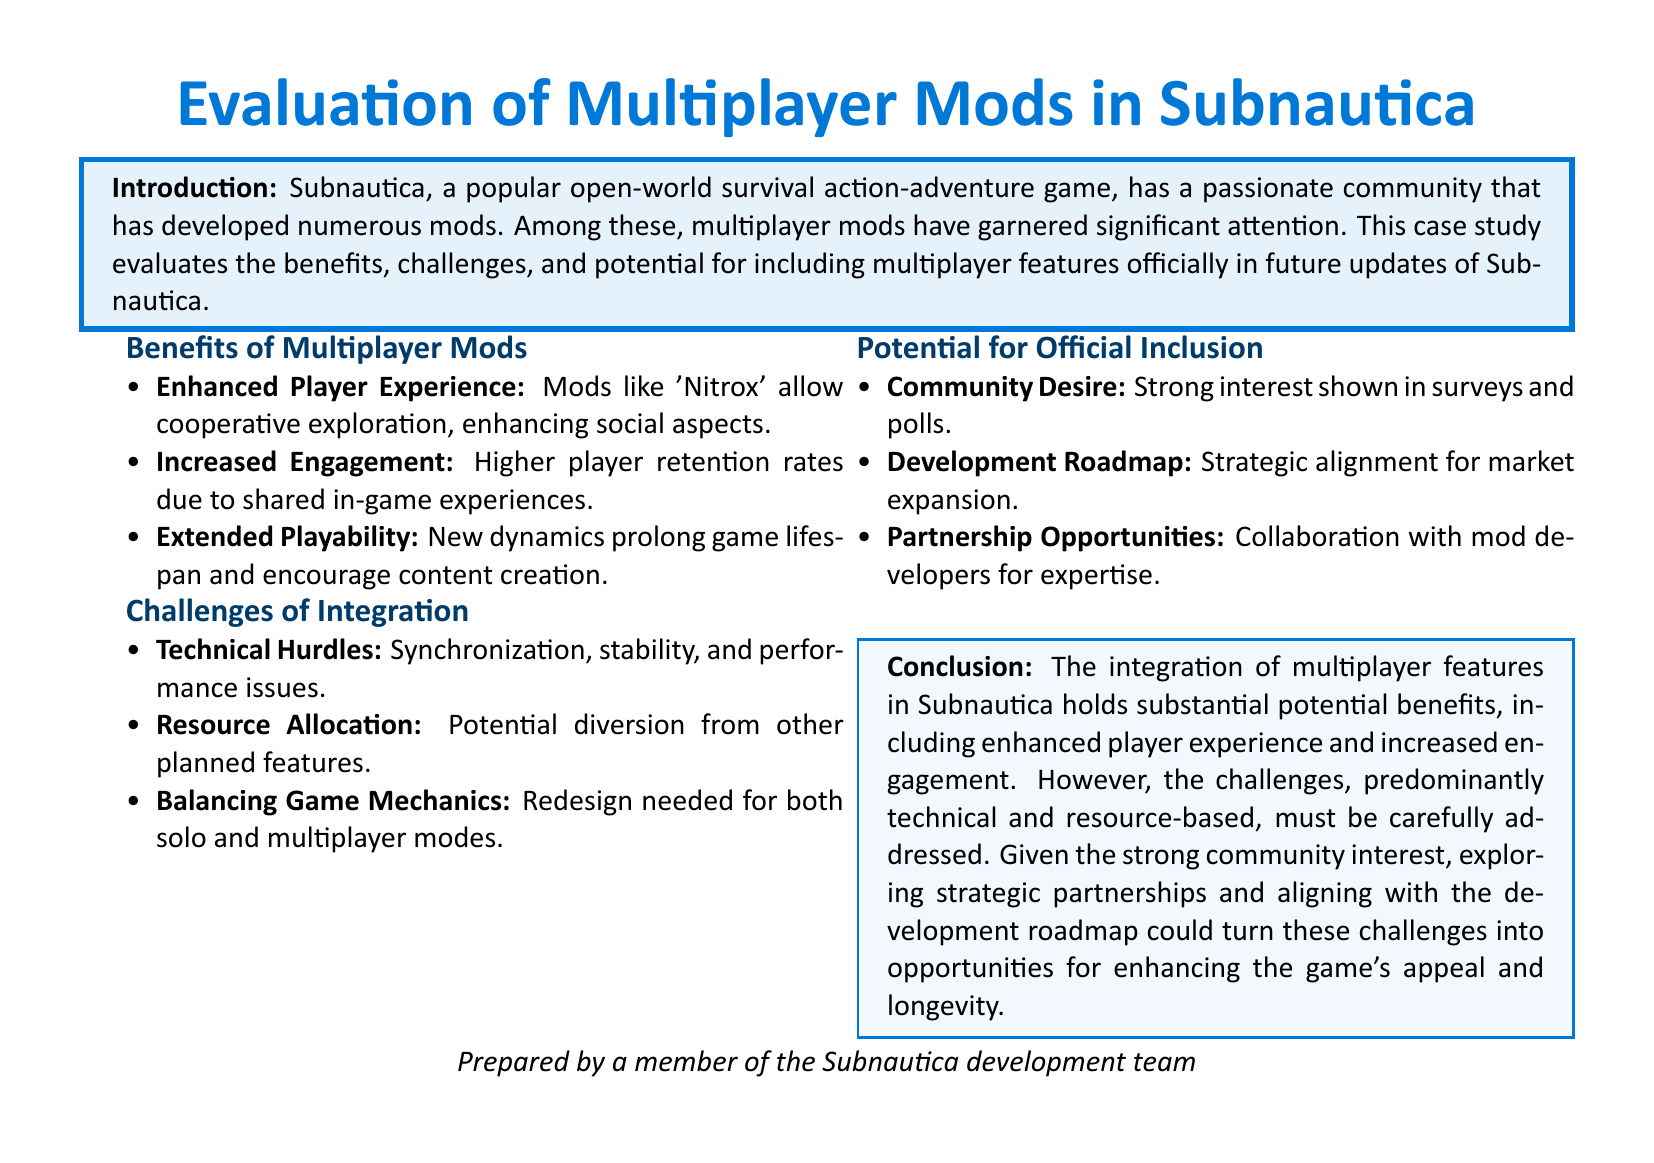What is the title of the case study? The title of the case study is provided at the beginning of the document.
Answer: Evaluation of Multiplayer Mods in Subnautica What mod is mentioned as allowing cooperative exploration? The mod referred to for cooperative exploration is named explicitly in the benefits section.
Answer: Nitrox What color is used for the header background? The color defined for the header background is specified in the document.
Answer: subnauticablue What is one benefit of multiplayer mods mentioned? Benefits listed in the document include enhancements to gameplay, which can be referenced from the benefits section.
Answer: Enhanced Player Experience What is one challenge of integration identified? The document clearly outlines the challenges in the integration section, where one challenge is explicitly stated.
Answer: Technical Hurdles According to the conclusion, what is the conclusion about community interest? Insights about community interest are provided in the conclusion, highlighting its significance.
Answer: Strong community interest What does the document suggest for strategic partnerships? The potential for collaboration with mod developers is outlined in the potential inclusion section.
Answer: Collaboration with mod developers What are the two areas highlighted as major challenges in the integration? The major areas specified about challenges in the document can be found in a structured list.
Answer: Technical and resource-based What is the key theme of the case study? The key theme revolves around the evaluation of multiplayer mods and their implications for the game.
Answer: Evaluation of multiplayer mods 